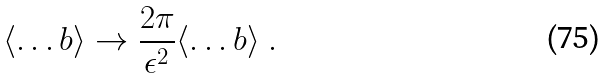<formula> <loc_0><loc_0><loc_500><loc_500>\langle \dots b \rangle \to \frac { 2 \pi } { \epsilon ^ { 2 } } \langle \dots b \rangle \ .</formula> 